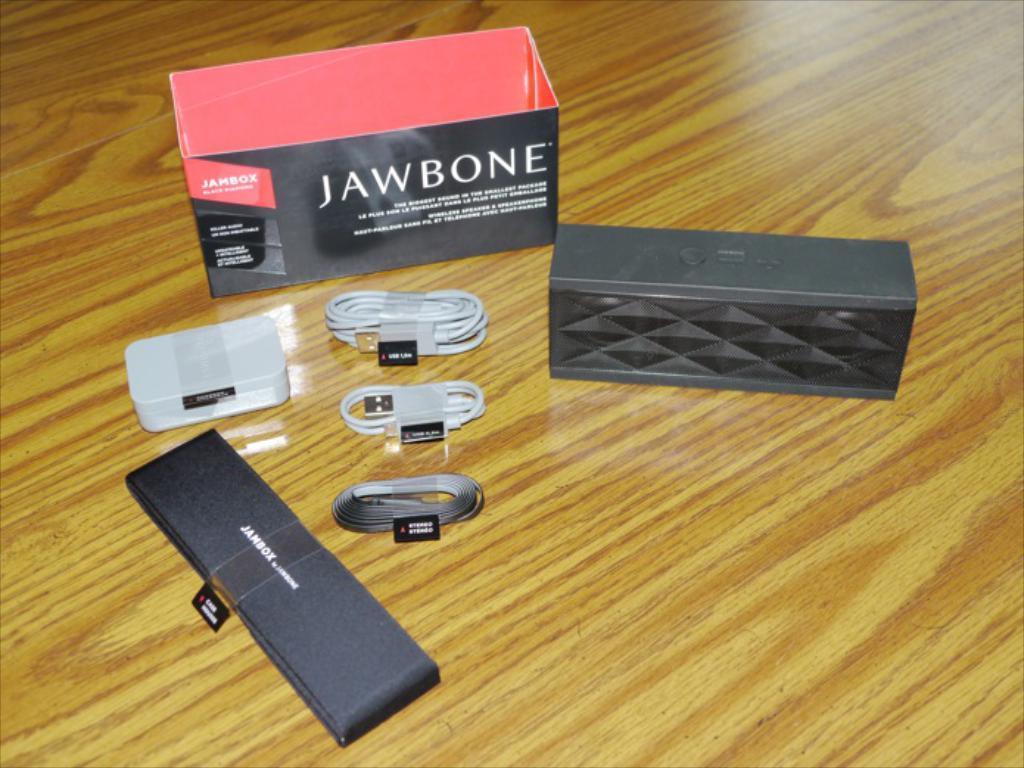In one or two sentences, can you explain what this image depicts? In this picture we can see boxes, data cables with stickers and these all are placed on a platform. 